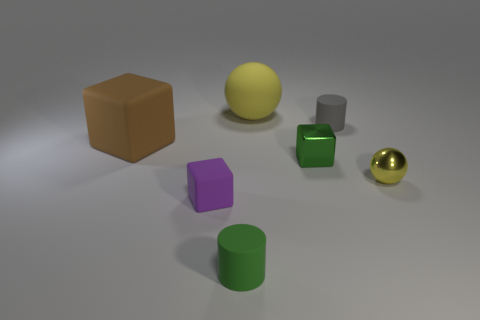What shape is the green metal thing that is the same size as the yellow shiny thing?
Make the answer very short. Cube. What number of rubber cylinders are the same color as the large cube?
Offer a very short reply. 0. Are the yellow sphere on the left side of the tiny shiny block and the tiny purple thing made of the same material?
Offer a very short reply. Yes. What shape is the green rubber thing?
Your response must be concise. Cylinder. What number of blue objects are either rubber cylinders or tiny matte objects?
Your response must be concise. 0. How many other objects are there of the same material as the small purple cube?
Your response must be concise. 4. Is the shape of the small matte object behind the yellow metallic sphere the same as  the yellow rubber object?
Provide a short and direct response. No. Is there a green metallic cylinder?
Provide a short and direct response. No. Is there any other thing that is the same shape as the tiny purple rubber thing?
Make the answer very short. Yes. Are there more small yellow things in front of the green cube than purple matte things?
Provide a succinct answer. No. 